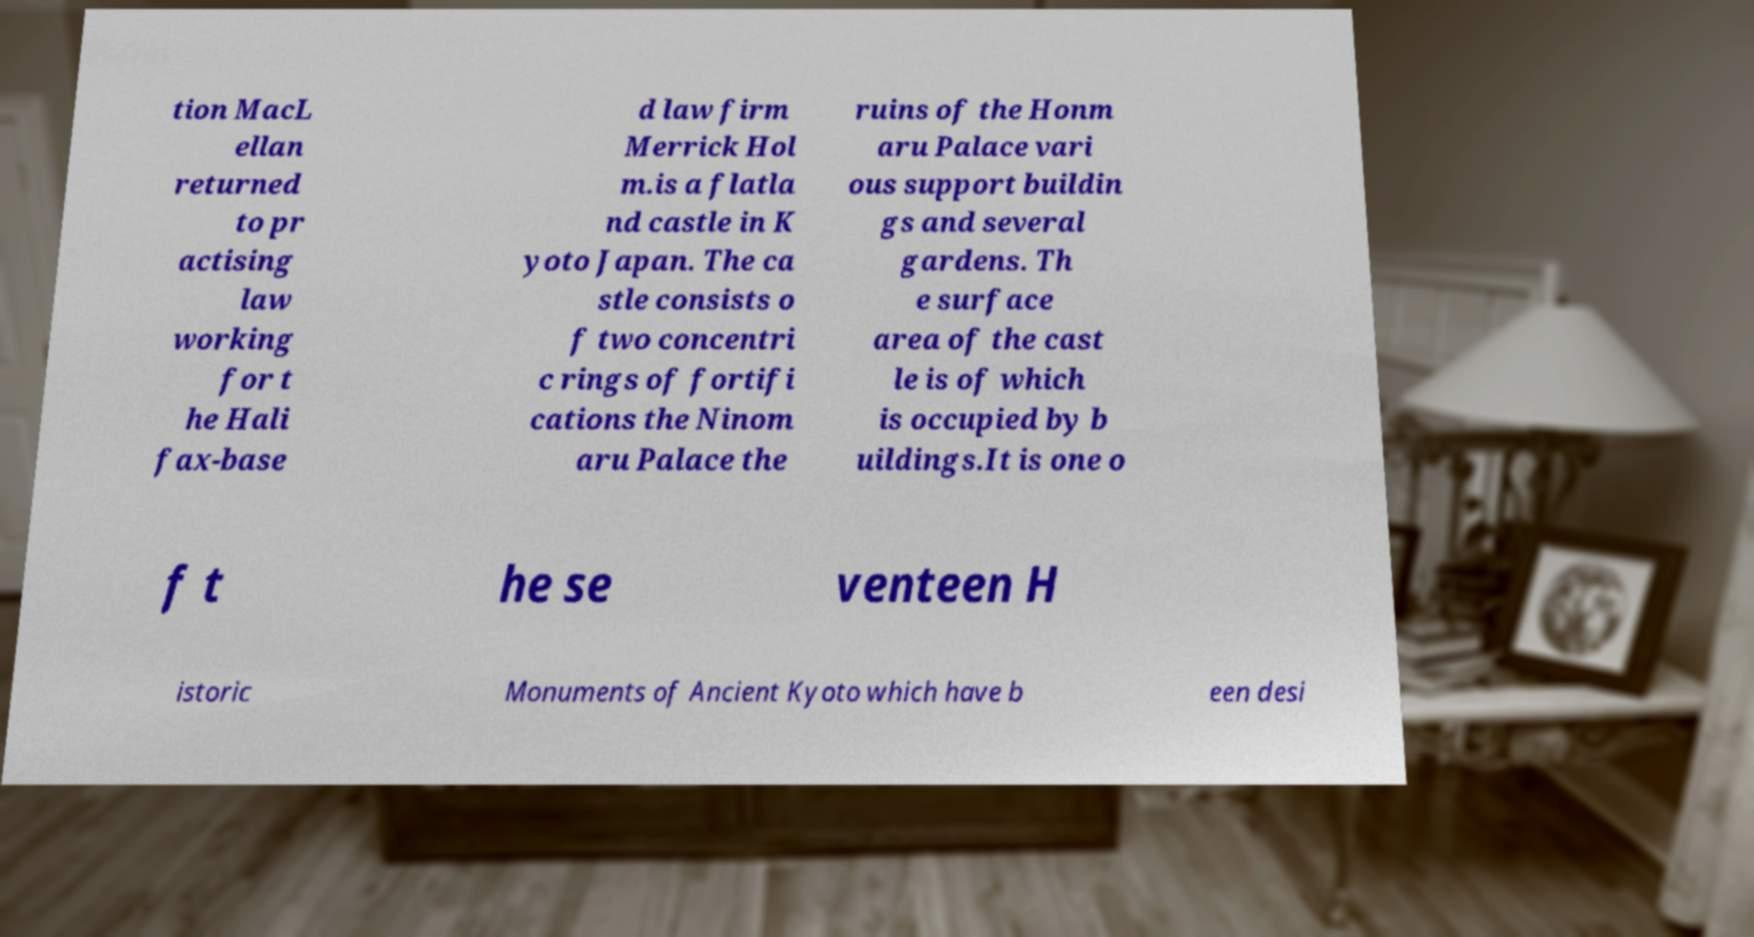What messages or text are displayed in this image? I need them in a readable, typed format. tion MacL ellan returned to pr actising law working for t he Hali fax-base d law firm Merrick Hol m.is a flatla nd castle in K yoto Japan. The ca stle consists o f two concentri c rings of fortifi cations the Ninom aru Palace the ruins of the Honm aru Palace vari ous support buildin gs and several gardens. Th e surface area of the cast le is of which is occupied by b uildings.It is one o f t he se venteen H istoric Monuments of Ancient Kyoto which have b een desi 